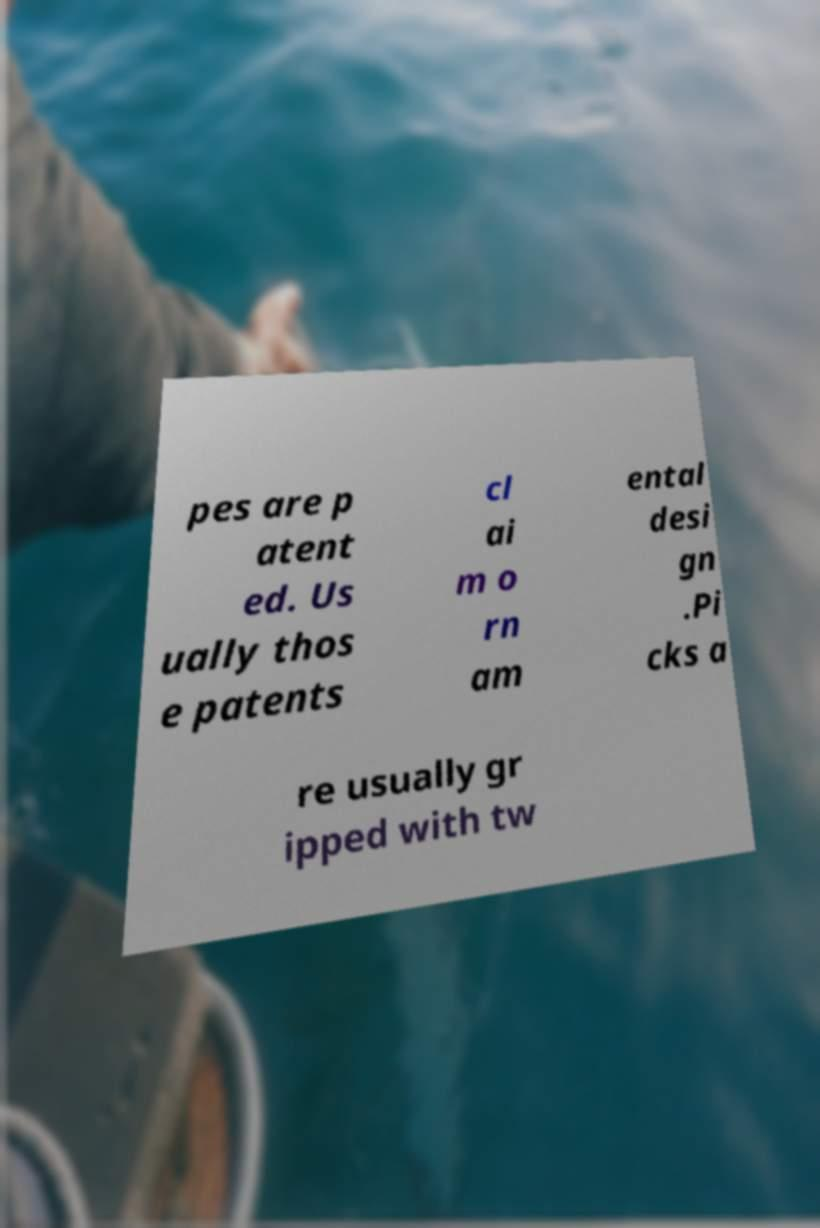For documentation purposes, I need the text within this image transcribed. Could you provide that? pes are p atent ed. Us ually thos e patents cl ai m o rn am ental desi gn .Pi cks a re usually gr ipped with tw 